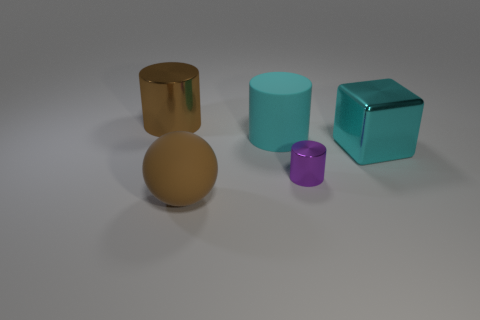Subtract 1 cylinders. How many cylinders are left? 2 Add 2 cyan shiny spheres. How many objects exist? 7 Subtract all metallic cylinders. How many cylinders are left? 1 Subtract all cylinders. How many objects are left? 2 Add 5 cyan metal things. How many cyan metal things exist? 6 Subtract 0 purple balls. How many objects are left? 5 Subtract all big cyan rubber objects. Subtract all cubes. How many objects are left? 3 Add 5 brown rubber things. How many brown rubber things are left? 6 